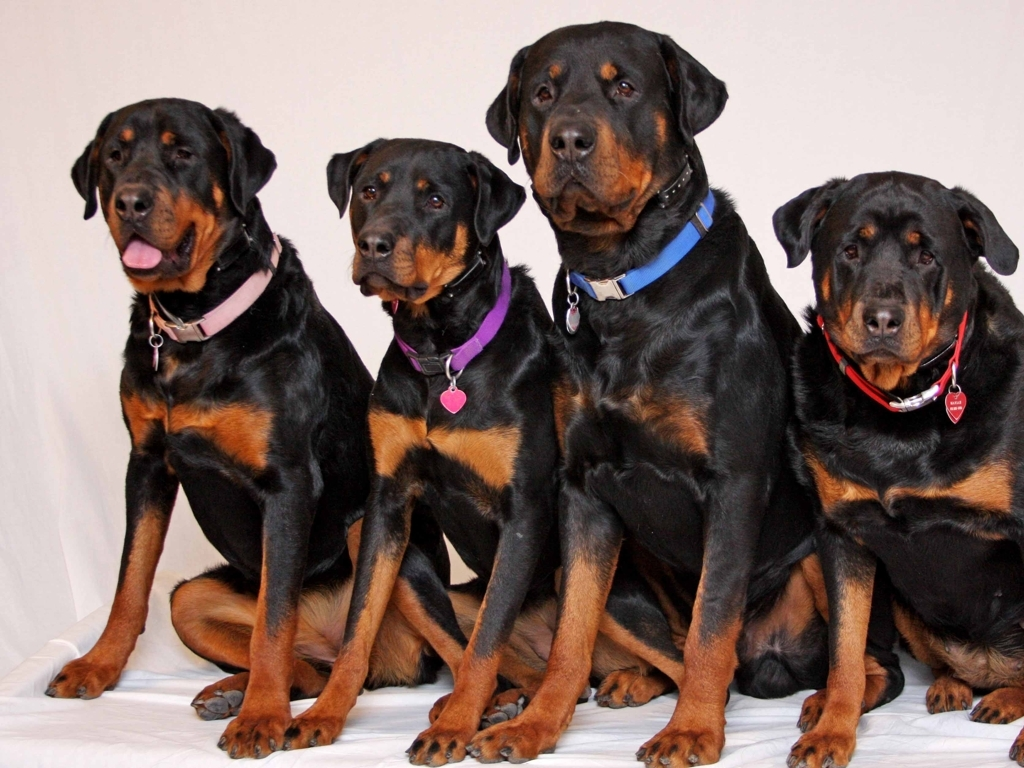What kind of care do these dogs need? Rottweilers are strong and active dogs that require regular exercise to maintain their physical and mental health. They benefit from activities like long walks, play sessions, and tasks that stimulate their intelligent minds. A diet appropriate to their size and energy level is crucial. Additionally, socialization and consistent training are key to managing their protective instincts. Caring for their coat is relatively straightforward with regular brushing, and they should also receive routine veterinary check-ups to ensure their overall well-being. 